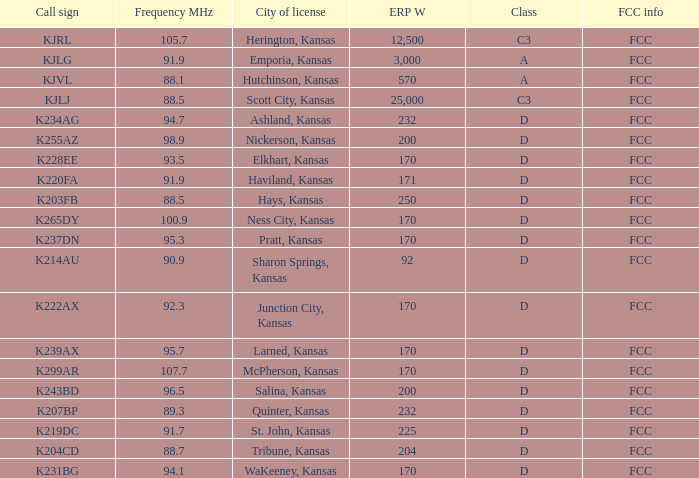Would you be able to parse every entry in this table? {'header': ['Call sign', 'Frequency MHz', 'City of license', 'ERP W', 'Class', 'FCC info'], 'rows': [['KJRL', '105.7', 'Herington, Kansas', '12,500', 'C3', 'FCC'], ['KJLG', '91.9', 'Emporia, Kansas', '3,000', 'A', 'FCC'], ['KJVL', '88.1', 'Hutchinson, Kansas', '570', 'A', 'FCC'], ['KJLJ', '88.5', 'Scott City, Kansas', '25,000', 'C3', 'FCC'], ['K234AG', '94.7', 'Ashland, Kansas', '232', 'D', 'FCC'], ['K255AZ', '98.9', 'Nickerson, Kansas', '200', 'D', 'FCC'], ['K228EE', '93.5', 'Elkhart, Kansas', '170', 'D', 'FCC'], ['K220FA', '91.9', 'Haviland, Kansas', '171', 'D', 'FCC'], ['K203FB', '88.5', 'Hays, Kansas', '250', 'D', 'FCC'], ['K265DY', '100.9', 'Ness City, Kansas', '170', 'D', 'FCC'], ['K237DN', '95.3', 'Pratt, Kansas', '170', 'D', 'FCC'], ['K214AU', '90.9', 'Sharon Springs, Kansas', '92', 'D', 'FCC'], ['K222AX', '92.3', 'Junction City, Kansas', '170', 'D', 'FCC'], ['K239AX', '95.7', 'Larned, Kansas', '170', 'D', 'FCC'], ['K299AR', '107.7', 'McPherson, Kansas', '170', 'D', 'FCC'], ['K243BD', '96.5', 'Salina, Kansas', '200', 'D', 'FCC'], ['K207BP', '89.3', 'Quinter, Kansas', '232', 'D', 'FCC'], ['K219DC', '91.7', 'St. John, Kansas', '225', 'D', 'FCC'], ['K204CD', '88.7', 'Tribune, Kansas', '204', 'D', 'FCC'], ['K231BG', '94.1', 'WaKeeney, Kansas', '170', 'D', 'FCC']]} Frequency MHz of 88.7 had what average erp w? 204.0. 